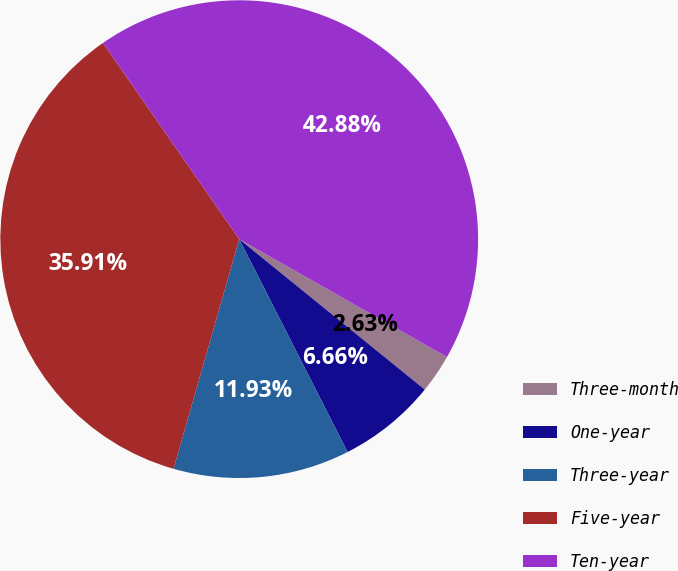<chart> <loc_0><loc_0><loc_500><loc_500><pie_chart><fcel>Three-month<fcel>One-year<fcel>Three-year<fcel>Five-year<fcel>Ten-year<nl><fcel>2.63%<fcel>6.66%<fcel>11.93%<fcel>35.91%<fcel>42.88%<nl></chart> 